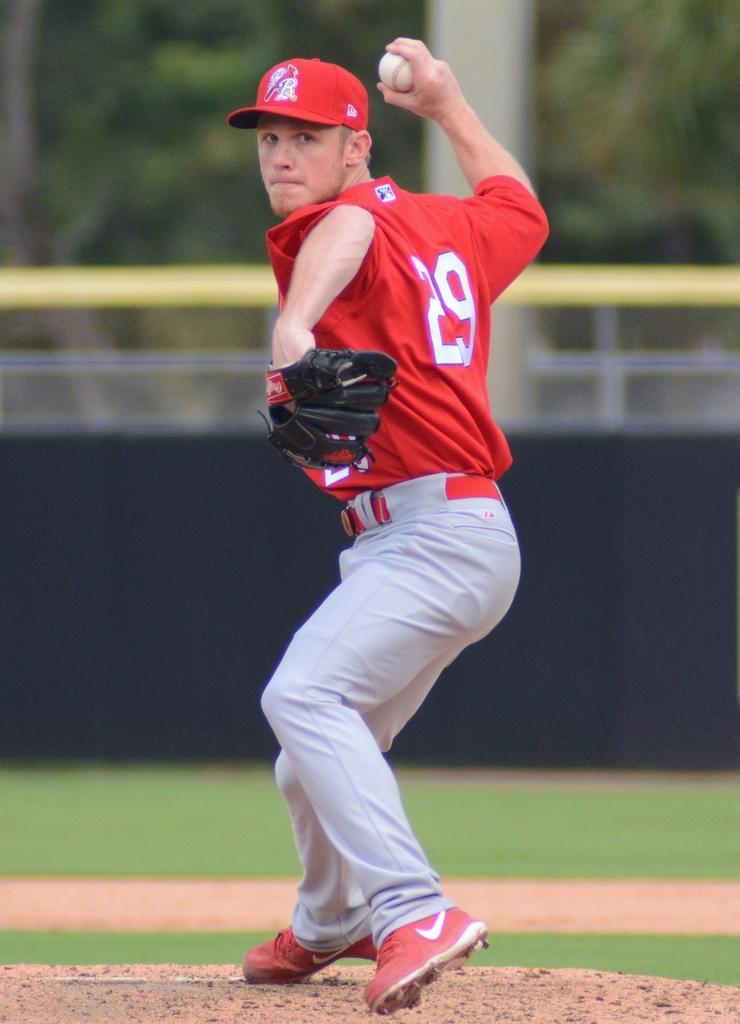Please provide a concise description of this image. In this image there is a man, he is wearing red color T-shirt, grey color pant, red color shoes and red color cap holding a ball in his hand and in the background it is blurred. 